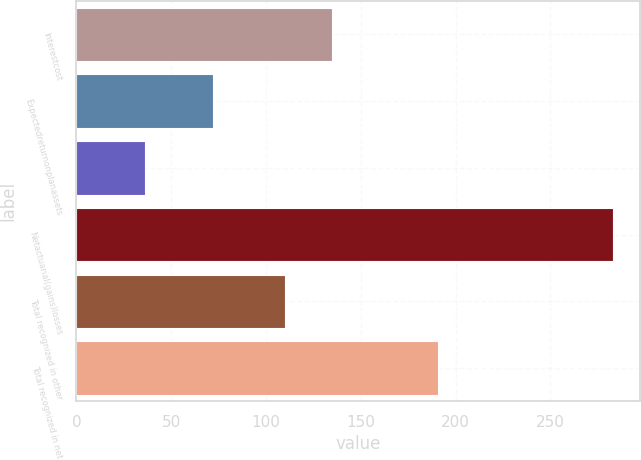<chart> <loc_0><loc_0><loc_500><loc_500><bar_chart><fcel>Interestcost<fcel>Expectedreturnonplanassets<fcel>Unnamed: 2<fcel>Netactuarial(gains)losses<fcel>Total recognized in other<fcel>Total recognized in net<nl><fcel>134.7<fcel>72<fcel>36<fcel>283<fcel>110<fcel>191<nl></chart> 